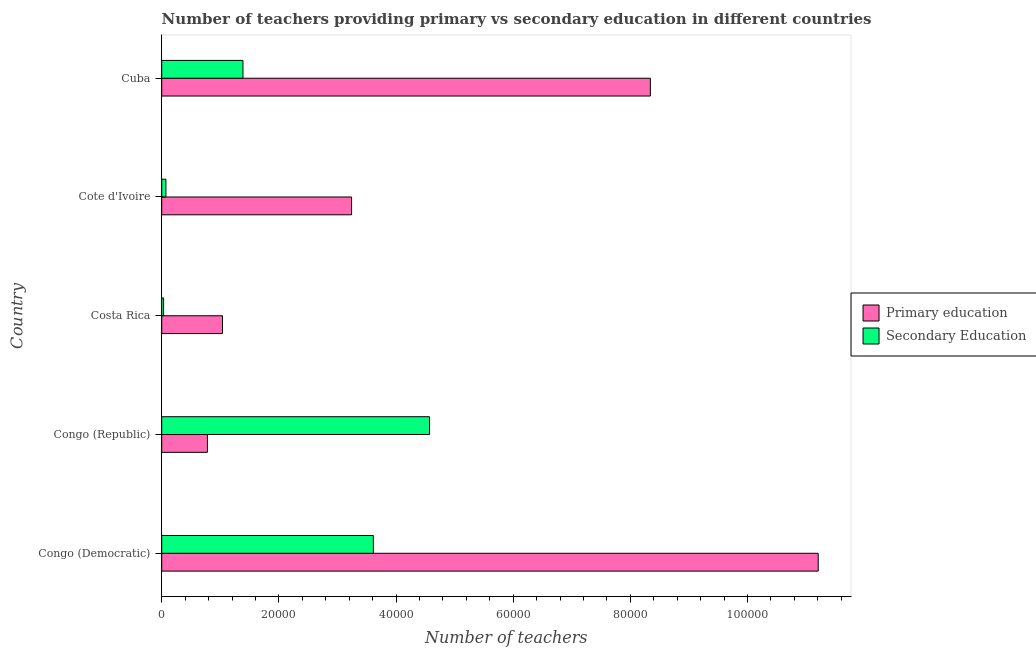Are the number of bars on each tick of the Y-axis equal?
Give a very brief answer. Yes. How many bars are there on the 2nd tick from the top?
Your answer should be very brief. 2. What is the label of the 1st group of bars from the top?
Give a very brief answer. Cuba. In how many cases, is the number of bars for a given country not equal to the number of legend labels?
Offer a very short reply. 0. What is the number of secondary teachers in Congo (Republic)?
Offer a terse response. 4.57e+04. Across all countries, what is the maximum number of primary teachers?
Make the answer very short. 1.12e+05. Across all countries, what is the minimum number of primary teachers?
Provide a short and direct response. 7803. In which country was the number of secondary teachers maximum?
Offer a very short reply. Congo (Republic). In which country was the number of secondary teachers minimum?
Provide a succinct answer. Costa Rica. What is the total number of primary teachers in the graph?
Make the answer very short. 2.46e+05. What is the difference between the number of primary teachers in Costa Rica and that in Cuba?
Offer a very short reply. -7.30e+04. What is the difference between the number of primary teachers in Cuba and the number of secondary teachers in Congo (Republic)?
Offer a terse response. 3.77e+04. What is the average number of secondary teachers per country?
Your answer should be very brief. 1.94e+04. What is the difference between the number of primary teachers and number of secondary teachers in Congo (Democratic)?
Give a very brief answer. 7.59e+04. What is the ratio of the number of secondary teachers in Congo (Republic) to that in Cuba?
Your answer should be compact. 3.3. Is the number of secondary teachers in Congo (Democratic) less than that in Cote d'Ivoire?
Keep it short and to the point. No. What is the difference between the highest and the second highest number of secondary teachers?
Offer a terse response. 9579. What is the difference between the highest and the lowest number of primary teachers?
Provide a short and direct response. 1.04e+05. Is the sum of the number of secondary teachers in Congo (Democratic) and Congo (Republic) greater than the maximum number of primary teachers across all countries?
Give a very brief answer. No. What does the 2nd bar from the bottom in Cote d'Ivoire represents?
Make the answer very short. Secondary Education. What is the difference between two consecutive major ticks on the X-axis?
Your response must be concise. 2.00e+04. Does the graph contain any zero values?
Offer a terse response. No. Does the graph contain grids?
Your answer should be very brief. No. Where does the legend appear in the graph?
Provide a succinct answer. Center right. How many legend labels are there?
Provide a succinct answer. 2. What is the title of the graph?
Give a very brief answer. Number of teachers providing primary vs secondary education in different countries. Does "Gasoline" appear as one of the legend labels in the graph?
Provide a short and direct response. No. What is the label or title of the X-axis?
Keep it short and to the point. Number of teachers. What is the label or title of the Y-axis?
Your response must be concise. Country. What is the Number of teachers in Primary education in Congo (Democratic)?
Ensure brevity in your answer.  1.12e+05. What is the Number of teachers in Secondary Education in Congo (Democratic)?
Your answer should be compact. 3.61e+04. What is the Number of teachers of Primary education in Congo (Republic)?
Provide a short and direct response. 7803. What is the Number of teachers in Secondary Education in Congo (Republic)?
Make the answer very short. 4.57e+04. What is the Number of teachers in Primary education in Costa Rica?
Offer a terse response. 1.04e+04. What is the Number of teachers in Secondary Education in Costa Rica?
Your answer should be very brief. 321. What is the Number of teachers in Primary education in Cote d'Ivoire?
Your response must be concise. 3.24e+04. What is the Number of teachers in Secondary Education in Cote d'Ivoire?
Provide a short and direct response. 720. What is the Number of teachers of Primary education in Cuba?
Give a very brief answer. 8.34e+04. What is the Number of teachers of Secondary Education in Cuba?
Ensure brevity in your answer.  1.39e+04. Across all countries, what is the maximum Number of teachers of Primary education?
Provide a succinct answer. 1.12e+05. Across all countries, what is the maximum Number of teachers in Secondary Education?
Give a very brief answer. 4.57e+04. Across all countries, what is the minimum Number of teachers in Primary education?
Make the answer very short. 7803. Across all countries, what is the minimum Number of teachers of Secondary Education?
Keep it short and to the point. 321. What is the total Number of teachers of Primary education in the graph?
Make the answer very short. 2.46e+05. What is the total Number of teachers in Secondary Education in the graph?
Ensure brevity in your answer.  9.68e+04. What is the difference between the Number of teachers in Primary education in Congo (Democratic) and that in Congo (Republic)?
Provide a short and direct response. 1.04e+05. What is the difference between the Number of teachers of Secondary Education in Congo (Democratic) and that in Congo (Republic)?
Your answer should be very brief. -9579. What is the difference between the Number of teachers of Primary education in Congo (Democratic) and that in Costa Rica?
Ensure brevity in your answer.  1.02e+05. What is the difference between the Number of teachers of Secondary Education in Congo (Democratic) and that in Costa Rica?
Provide a succinct answer. 3.58e+04. What is the difference between the Number of teachers in Primary education in Congo (Democratic) and that in Cote d'Ivoire?
Offer a terse response. 7.97e+04. What is the difference between the Number of teachers of Secondary Education in Congo (Democratic) and that in Cote d'Ivoire?
Offer a terse response. 3.54e+04. What is the difference between the Number of teachers in Primary education in Congo (Democratic) and that in Cuba?
Give a very brief answer. 2.87e+04. What is the difference between the Number of teachers of Secondary Education in Congo (Democratic) and that in Cuba?
Your answer should be very brief. 2.23e+04. What is the difference between the Number of teachers in Primary education in Congo (Republic) and that in Costa Rica?
Offer a terse response. -2576. What is the difference between the Number of teachers of Secondary Education in Congo (Republic) and that in Costa Rica?
Your response must be concise. 4.54e+04. What is the difference between the Number of teachers of Primary education in Congo (Republic) and that in Cote d'Ivoire?
Offer a terse response. -2.46e+04. What is the difference between the Number of teachers of Secondary Education in Congo (Republic) and that in Cote d'Ivoire?
Offer a very short reply. 4.50e+04. What is the difference between the Number of teachers in Primary education in Congo (Republic) and that in Cuba?
Provide a succinct answer. -7.56e+04. What is the difference between the Number of teachers of Secondary Education in Congo (Republic) and that in Cuba?
Offer a terse response. 3.18e+04. What is the difference between the Number of teachers of Primary education in Costa Rica and that in Cote d'Ivoire?
Offer a terse response. -2.20e+04. What is the difference between the Number of teachers in Secondary Education in Costa Rica and that in Cote d'Ivoire?
Your answer should be very brief. -399. What is the difference between the Number of teachers of Primary education in Costa Rica and that in Cuba?
Your response must be concise. -7.30e+04. What is the difference between the Number of teachers of Secondary Education in Costa Rica and that in Cuba?
Your answer should be very brief. -1.36e+04. What is the difference between the Number of teachers in Primary education in Cote d'Ivoire and that in Cuba?
Offer a very short reply. -5.10e+04. What is the difference between the Number of teachers of Secondary Education in Cote d'Ivoire and that in Cuba?
Your response must be concise. -1.32e+04. What is the difference between the Number of teachers of Primary education in Congo (Democratic) and the Number of teachers of Secondary Education in Congo (Republic)?
Provide a short and direct response. 6.64e+04. What is the difference between the Number of teachers of Primary education in Congo (Democratic) and the Number of teachers of Secondary Education in Costa Rica?
Ensure brevity in your answer.  1.12e+05. What is the difference between the Number of teachers in Primary education in Congo (Democratic) and the Number of teachers in Secondary Education in Cote d'Ivoire?
Your answer should be very brief. 1.11e+05. What is the difference between the Number of teachers of Primary education in Congo (Democratic) and the Number of teachers of Secondary Education in Cuba?
Your answer should be very brief. 9.82e+04. What is the difference between the Number of teachers of Primary education in Congo (Republic) and the Number of teachers of Secondary Education in Costa Rica?
Give a very brief answer. 7482. What is the difference between the Number of teachers of Primary education in Congo (Republic) and the Number of teachers of Secondary Education in Cote d'Ivoire?
Offer a terse response. 7083. What is the difference between the Number of teachers of Primary education in Congo (Republic) and the Number of teachers of Secondary Education in Cuba?
Offer a very short reply. -6068. What is the difference between the Number of teachers in Primary education in Costa Rica and the Number of teachers in Secondary Education in Cote d'Ivoire?
Provide a short and direct response. 9659. What is the difference between the Number of teachers of Primary education in Costa Rica and the Number of teachers of Secondary Education in Cuba?
Offer a terse response. -3492. What is the difference between the Number of teachers of Primary education in Cote d'Ivoire and the Number of teachers of Secondary Education in Cuba?
Offer a terse response. 1.85e+04. What is the average Number of teachers in Primary education per country?
Offer a very short reply. 4.92e+04. What is the average Number of teachers of Secondary Education per country?
Your answer should be compact. 1.94e+04. What is the difference between the Number of teachers in Primary education and Number of teachers in Secondary Education in Congo (Democratic)?
Keep it short and to the point. 7.59e+04. What is the difference between the Number of teachers of Primary education and Number of teachers of Secondary Education in Congo (Republic)?
Keep it short and to the point. -3.79e+04. What is the difference between the Number of teachers of Primary education and Number of teachers of Secondary Education in Costa Rica?
Offer a very short reply. 1.01e+04. What is the difference between the Number of teachers in Primary education and Number of teachers in Secondary Education in Cote d'Ivoire?
Offer a very short reply. 3.17e+04. What is the difference between the Number of teachers of Primary education and Number of teachers of Secondary Education in Cuba?
Your response must be concise. 6.96e+04. What is the ratio of the Number of teachers in Primary education in Congo (Democratic) to that in Congo (Republic)?
Make the answer very short. 14.36. What is the ratio of the Number of teachers of Secondary Education in Congo (Democratic) to that in Congo (Republic)?
Your answer should be very brief. 0.79. What is the ratio of the Number of teachers of Primary education in Congo (Democratic) to that in Costa Rica?
Offer a terse response. 10.8. What is the ratio of the Number of teachers of Secondary Education in Congo (Democratic) to that in Costa Rica?
Your response must be concise. 112.57. What is the ratio of the Number of teachers in Primary education in Congo (Democratic) to that in Cote d'Ivoire?
Ensure brevity in your answer.  3.46. What is the ratio of the Number of teachers of Secondary Education in Congo (Democratic) to that in Cote d'Ivoire?
Keep it short and to the point. 50.19. What is the ratio of the Number of teachers of Primary education in Congo (Democratic) to that in Cuba?
Ensure brevity in your answer.  1.34. What is the ratio of the Number of teachers in Secondary Education in Congo (Democratic) to that in Cuba?
Make the answer very short. 2.61. What is the ratio of the Number of teachers of Primary education in Congo (Republic) to that in Costa Rica?
Provide a succinct answer. 0.75. What is the ratio of the Number of teachers of Secondary Education in Congo (Republic) to that in Costa Rica?
Offer a terse response. 142.41. What is the ratio of the Number of teachers in Primary education in Congo (Republic) to that in Cote d'Ivoire?
Offer a very short reply. 0.24. What is the ratio of the Number of teachers of Secondary Education in Congo (Republic) to that in Cote d'Ivoire?
Give a very brief answer. 63.49. What is the ratio of the Number of teachers in Primary education in Congo (Republic) to that in Cuba?
Offer a very short reply. 0.09. What is the ratio of the Number of teachers in Secondary Education in Congo (Republic) to that in Cuba?
Give a very brief answer. 3.3. What is the ratio of the Number of teachers in Primary education in Costa Rica to that in Cote d'Ivoire?
Make the answer very short. 0.32. What is the ratio of the Number of teachers in Secondary Education in Costa Rica to that in Cote d'Ivoire?
Provide a succinct answer. 0.45. What is the ratio of the Number of teachers in Primary education in Costa Rica to that in Cuba?
Offer a very short reply. 0.12. What is the ratio of the Number of teachers of Secondary Education in Costa Rica to that in Cuba?
Make the answer very short. 0.02. What is the ratio of the Number of teachers of Primary education in Cote d'Ivoire to that in Cuba?
Give a very brief answer. 0.39. What is the ratio of the Number of teachers in Secondary Education in Cote d'Ivoire to that in Cuba?
Provide a succinct answer. 0.05. What is the difference between the highest and the second highest Number of teachers in Primary education?
Your response must be concise. 2.87e+04. What is the difference between the highest and the second highest Number of teachers in Secondary Education?
Ensure brevity in your answer.  9579. What is the difference between the highest and the lowest Number of teachers of Primary education?
Your answer should be very brief. 1.04e+05. What is the difference between the highest and the lowest Number of teachers of Secondary Education?
Give a very brief answer. 4.54e+04. 